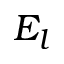Convert formula to latex. <formula><loc_0><loc_0><loc_500><loc_500>E _ { l }</formula> 